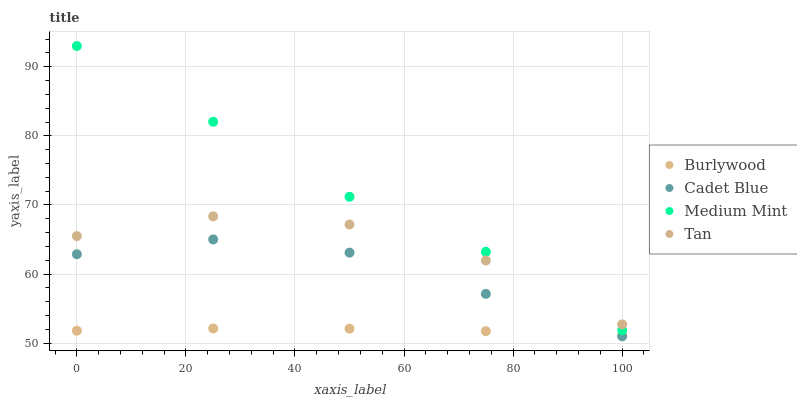Does Burlywood have the minimum area under the curve?
Answer yes or no. Yes. Does Medium Mint have the maximum area under the curve?
Answer yes or no. Yes. Does Tan have the minimum area under the curve?
Answer yes or no. No. Does Tan have the maximum area under the curve?
Answer yes or no. No. Is Burlywood the smoothest?
Answer yes or no. Yes. Is Tan the roughest?
Answer yes or no. Yes. Is Medium Mint the smoothest?
Answer yes or no. No. Is Medium Mint the roughest?
Answer yes or no. No. Does Cadet Blue have the lowest value?
Answer yes or no. Yes. Does Medium Mint have the lowest value?
Answer yes or no. No. Does Medium Mint have the highest value?
Answer yes or no. Yes. Does Tan have the highest value?
Answer yes or no. No. Is Burlywood less than Medium Mint?
Answer yes or no. Yes. Is Medium Mint greater than Burlywood?
Answer yes or no. Yes. Does Tan intersect Medium Mint?
Answer yes or no. Yes. Is Tan less than Medium Mint?
Answer yes or no. No. Is Tan greater than Medium Mint?
Answer yes or no. No. Does Burlywood intersect Medium Mint?
Answer yes or no. No. 